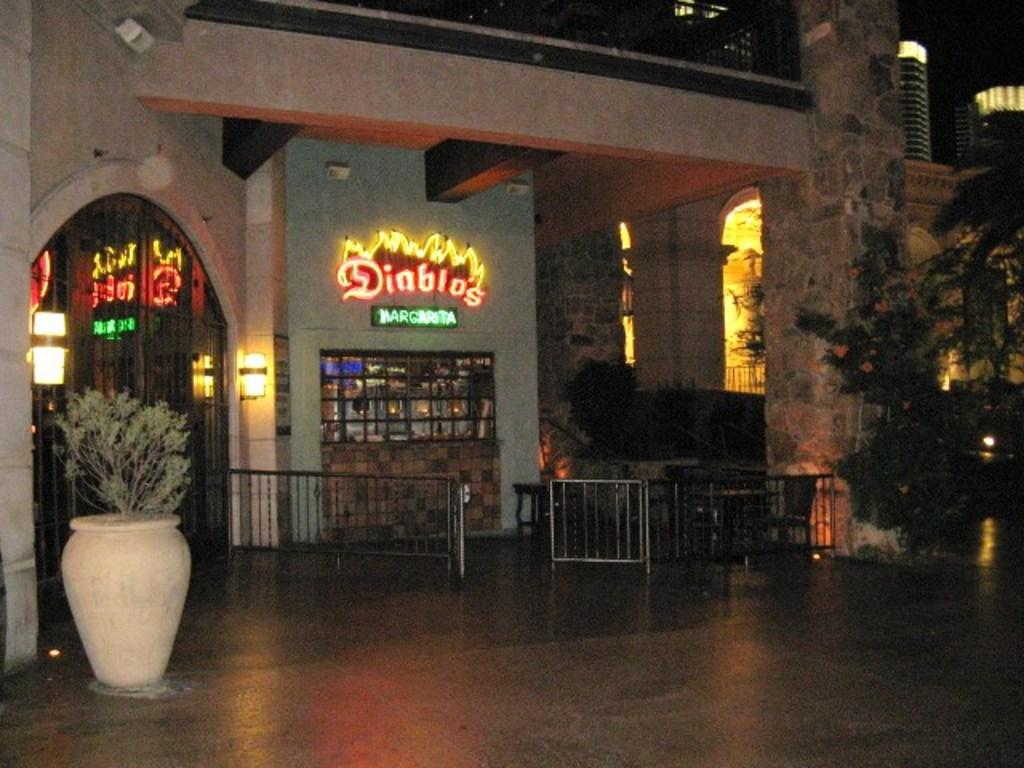What type of vegetation is present in the image? There is a plant and trees in the image. What can be seen near the plant? There is a railing in the image. What is visible structures are in the background of the image? There is a building with lights and LED boards in the background of the image. What is the color of the background in the image? The background of the image is black. Can you tell me how many patches of rice are visible in the image? There is no rice present in the image; it features a plant, trees, a railing, and a background with a building and LED boards. What type of creature is shown interacting with the plant in the image? There is no creature shown interacting with the plant in the image; only the plant, railing, trees, and background structures are present. 